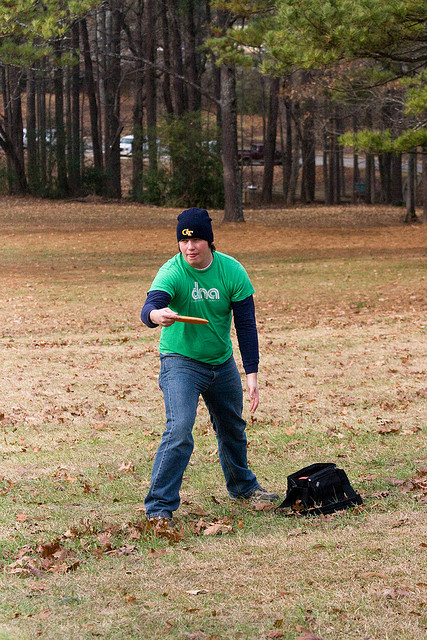<image>What is the job of the man standing to the far left in the picture? I don't know exactly what the job of the man on the far left is. Some suggest he could be throwing a frisbee or catching a frisbee, and others mention different professions. What is in the bag? It is unknown what is in the bag. It could potentially be sports equipment or a frisbee. What is the job of the man standing to the far left in the picture? I don't know what is the job of the man standing to the far left in the picture. What is in the bag? I don't know what is in the bag. It can be sports equipment, carrying items, grass, frisbee, leaves or nothing. 